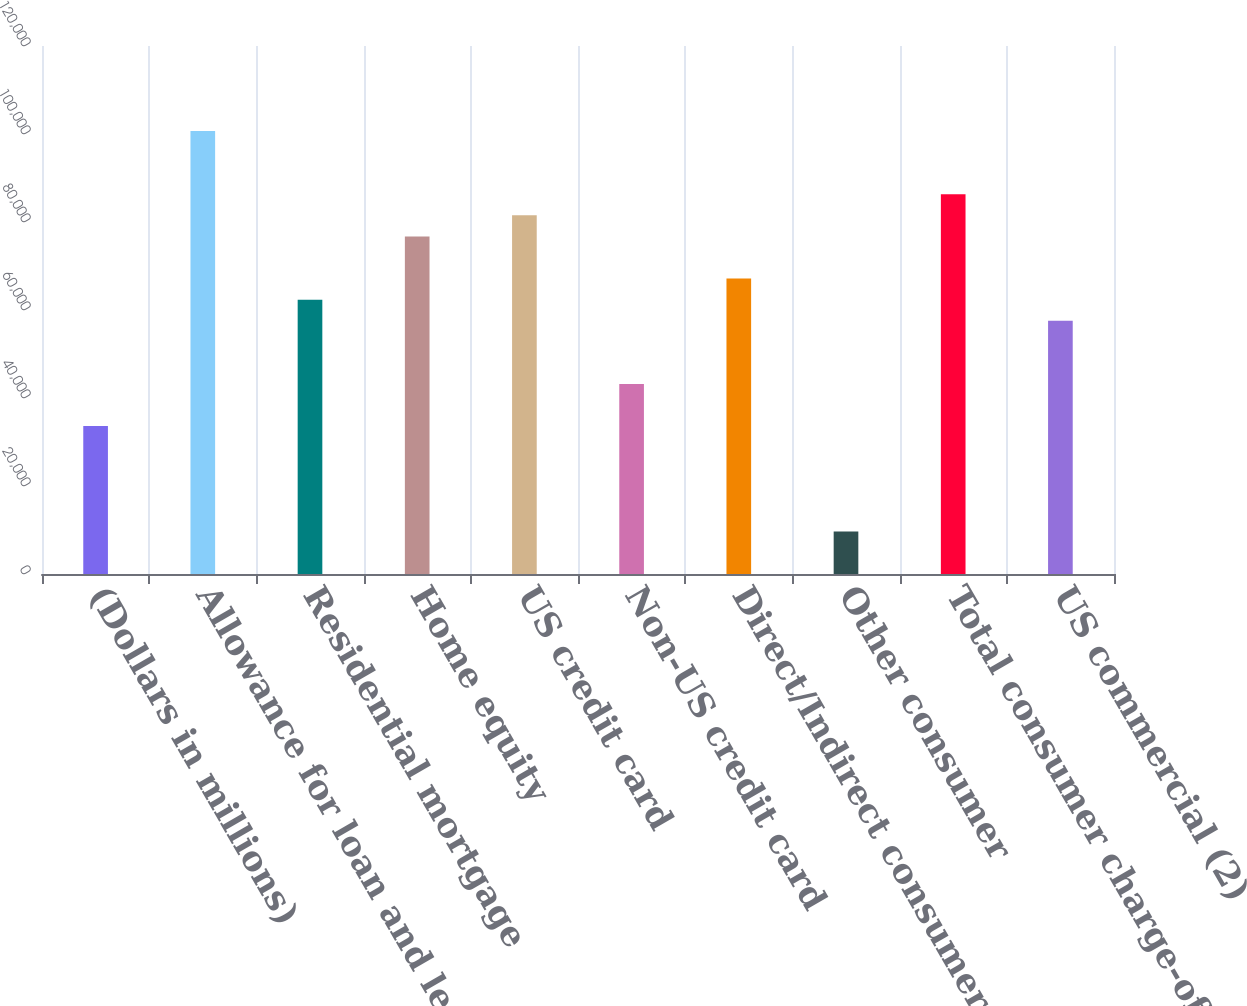<chart> <loc_0><loc_0><loc_500><loc_500><bar_chart><fcel>(Dollars in millions)<fcel>Allowance for loan and lease<fcel>Residential mortgage<fcel>Home equity<fcel>US credit card<fcel>Non-US credit card<fcel>Direct/Indirect consumer<fcel>Other consumer<fcel>Total consumer charge-offs<fcel>US commercial (2)<nl><fcel>33620.4<fcel>100669<fcel>62355.6<fcel>76723.2<fcel>81512.4<fcel>43198.8<fcel>67144.8<fcel>9674.4<fcel>86301.6<fcel>57566.4<nl></chart> 